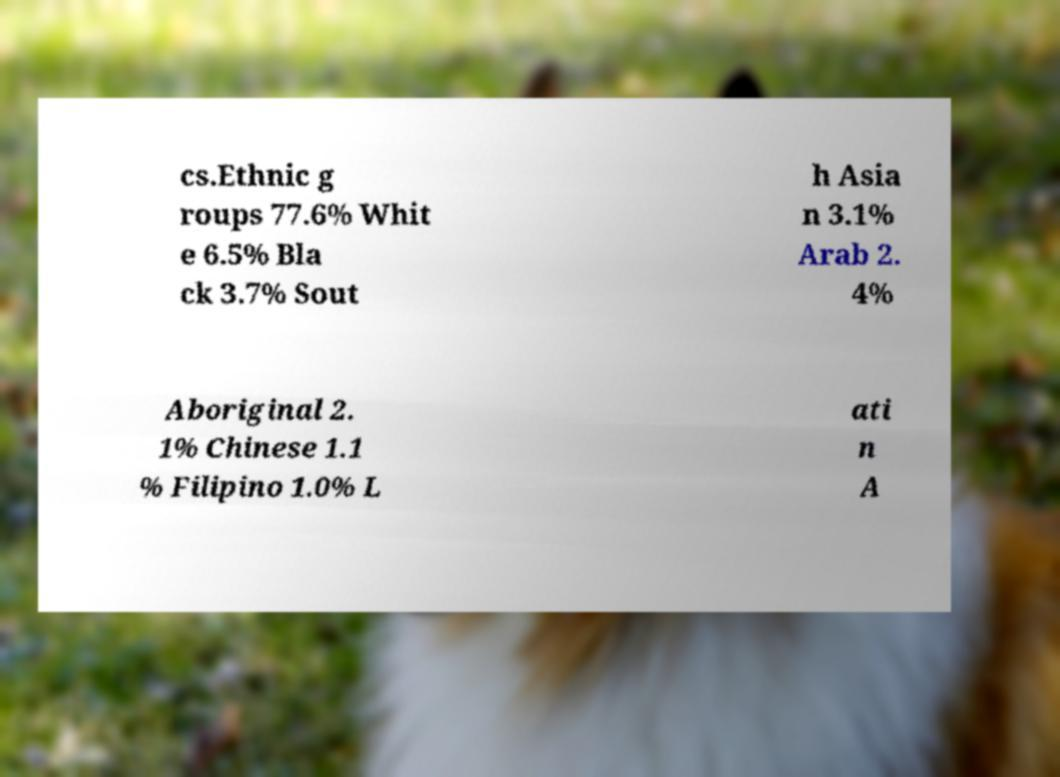Please read and relay the text visible in this image. What does it say? cs.Ethnic g roups 77.6% Whit e 6.5% Bla ck 3.7% Sout h Asia n 3.1% Arab 2. 4% Aboriginal 2. 1% Chinese 1.1 % Filipino 1.0% L ati n A 